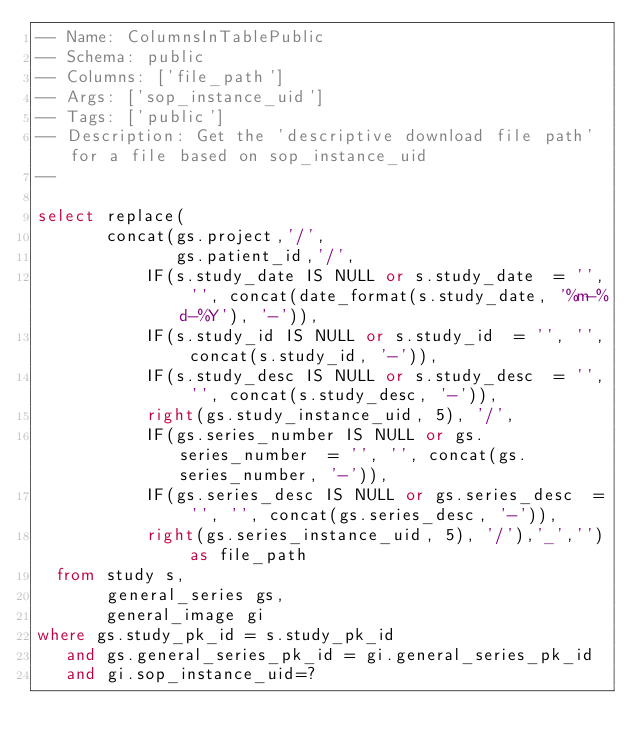Convert code to text. <code><loc_0><loc_0><loc_500><loc_500><_SQL_>-- Name: ColumnsInTablePublic
-- Schema: public
-- Columns: ['file_path']
-- Args: ['sop_instance_uid']
-- Tags: ['public']
-- Description: Get the 'descriptive download file path' for a file based on sop_instance_uid
-- 

select replace(
       concat(gs.project,'/',
              gs.patient_id,'/',
           IF(s.study_date IS NULL or s.study_date  = '', '', concat(date_format(s.study_date, '%m-%d-%Y'), '-')),
           IF(s.study_id IS NULL or s.study_id  = '', '', concat(s.study_id, '-')),
           IF(s.study_desc IS NULL or s.study_desc  = '', '', concat(s.study_desc, '-')),
           right(gs.study_instance_uid, 5), '/',
           IF(gs.series_number IS NULL or gs.series_number  = '', '', concat(gs.series_number, '-')),
           IF(gs.series_desc IS NULL or gs.series_desc  = '', '', concat(gs.series_desc, '-')),
           right(gs.series_instance_uid, 5), '/'),'_','') as file_path
  from study s,
       general_series gs,
       general_image gi
where gs.study_pk_id = s.study_pk_id
   and gs.general_series_pk_id = gi.general_series_pk_id
   and gi.sop_instance_uid=?</code> 